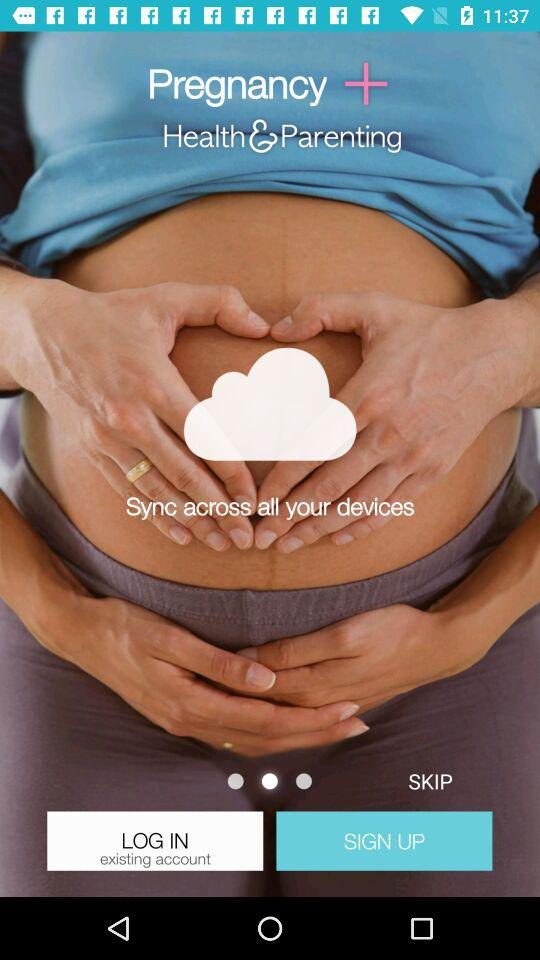What is the application name? The application name is "Pregnancy +". 